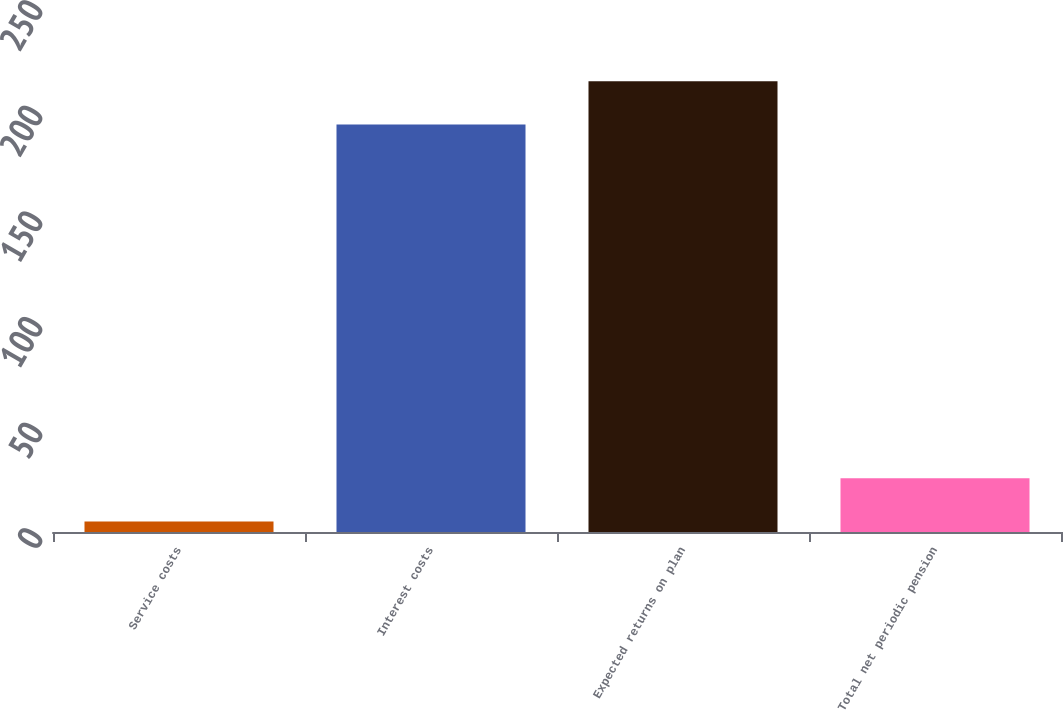Convert chart. <chart><loc_0><loc_0><loc_500><loc_500><bar_chart><fcel>Service costs<fcel>Interest costs<fcel>Expected returns on plan<fcel>Total net periodic pension<nl><fcel>5<fcel>193<fcel>213.4<fcel>25.4<nl></chart> 